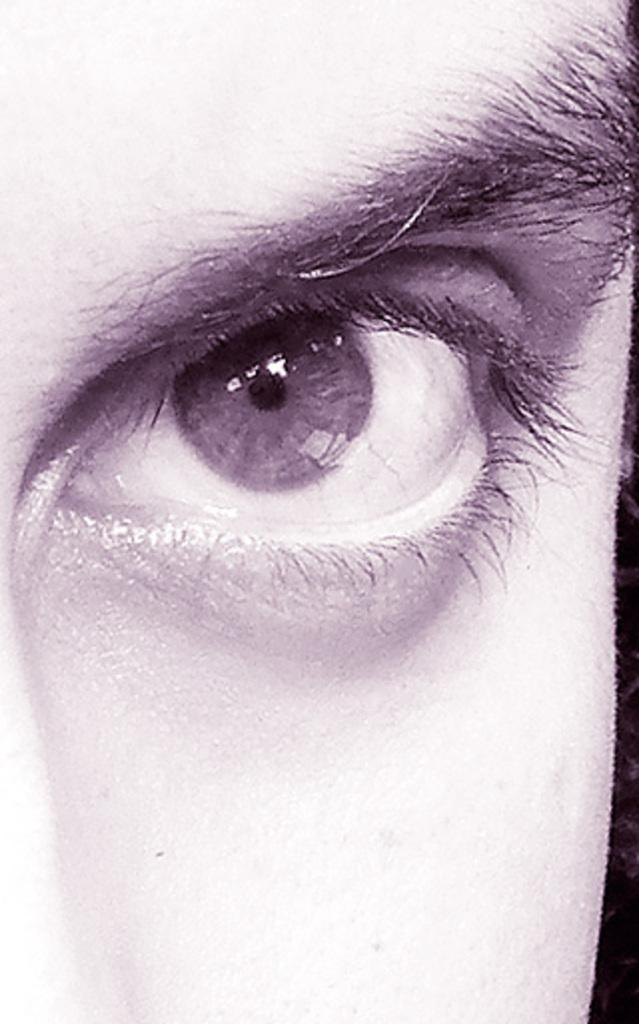What is the main focus of the image? The main focus of the image is an eye. What is located above the eye in the image? There is an eyebrow above the eye in the image. Can you see any other facial features in the image? A portion of the nose is visible in the left corner of the image. How many fairies are dancing around the eye in the image? There are no fairies present in the image. What is the mass of the eye in the image? It is not possible to determine the mass of the eye from the image alone. 